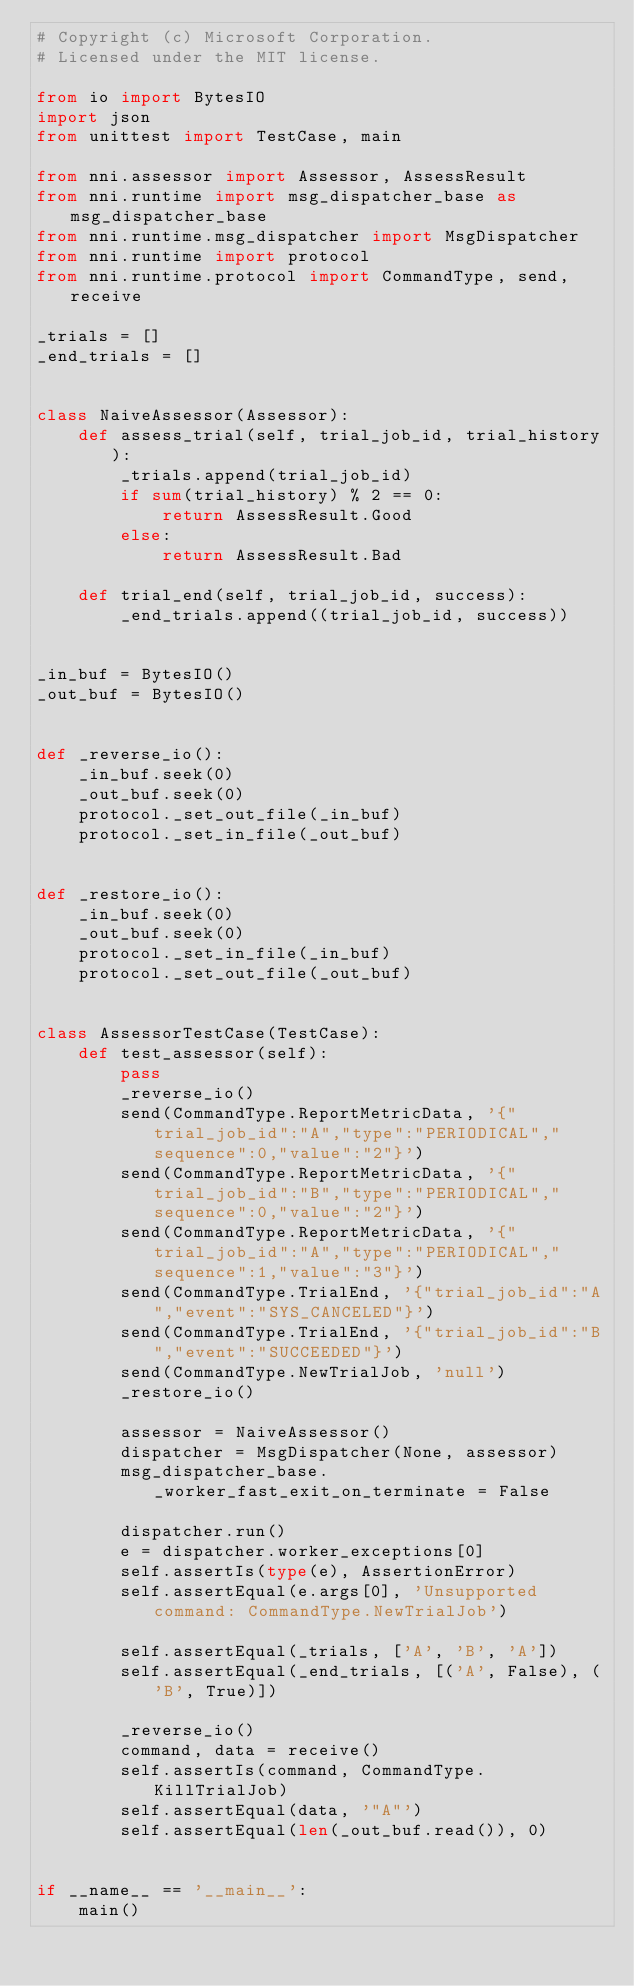<code> <loc_0><loc_0><loc_500><loc_500><_Python_># Copyright (c) Microsoft Corporation.
# Licensed under the MIT license.

from io import BytesIO
import json
from unittest import TestCase, main

from nni.assessor import Assessor, AssessResult
from nni.runtime import msg_dispatcher_base as msg_dispatcher_base
from nni.runtime.msg_dispatcher import MsgDispatcher
from nni.runtime import protocol
from nni.runtime.protocol import CommandType, send, receive

_trials = []
_end_trials = []


class NaiveAssessor(Assessor):
    def assess_trial(self, trial_job_id, trial_history):
        _trials.append(trial_job_id)
        if sum(trial_history) % 2 == 0:
            return AssessResult.Good
        else:
            return AssessResult.Bad

    def trial_end(self, trial_job_id, success):
        _end_trials.append((trial_job_id, success))


_in_buf = BytesIO()
_out_buf = BytesIO()


def _reverse_io():
    _in_buf.seek(0)
    _out_buf.seek(0)
    protocol._set_out_file(_in_buf)
    protocol._set_in_file(_out_buf)


def _restore_io():
    _in_buf.seek(0)
    _out_buf.seek(0)
    protocol._set_in_file(_in_buf)
    protocol._set_out_file(_out_buf)


class AssessorTestCase(TestCase):
    def test_assessor(self):
        pass
        _reverse_io()
        send(CommandType.ReportMetricData, '{"trial_job_id":"A","type":"PERIODICAL","sequence":0,"value":"2"}')
        send(CommandType.ReportMetricData, '{"trial_job_id":"B","type":"PERIODICAL","sequence":0,"value":"2"}')
        send(CommandType.ReportMetricData, '{"trial_job_id":"A","type":"PERIODICAL","sequence":1,"value":"3"}')
        send(CommandType.TrialEnd, '{"trial_job_id":"A","event":"SYS_CANCELED"}')
        send(CommandType.TrialEnd, '{"trial_job_id":"B","event":"SUCCEEDED"}')
        send(CommandType.NewTrialJob, 'null')
        _restore_io()

        assessor = NaiveAssessor()
        dispatcher = MsgDispatcher(None, assessor)
        msg_dispatcher_base._worker_fast_exit_on_terminate = False

        dispatcher.run()
        e = dispatcher.worker_exceptions[0]
        self.assertIs(type(e), AssertionError)
        self.assertEqual(e.args[0], 'Unsupported command: CommandType.NewTrialJob')

        self.assertEqual(_trials, ['A', 'B', 'A'])
        self.assertEqual(_end_trials, [('A', False), ('B', True)])

        _reverse_io()
        command, data = receive()
        self.assertIs(command, CommandType.KillTrialJob)
        self.assertEqual(data, '"A"')
        self.assertEqual(len(_out_buf.read()), 0)


if __name__ == '__main__':
    main()
</code> 